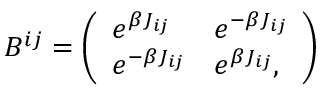<formula> <loc_0><loc_0><loc_500><loc_500>B ^ { i j } = \left ( \begin{array} { l l } { e ^ { \beta J _ { i j } } } & { e ^ { - \beta J _ { i j } } } \\ { e ^ { - \beta J _ { i j } } } & { e ^ { \beta J _ { i j } } , } \end{array} \right )</formula> 